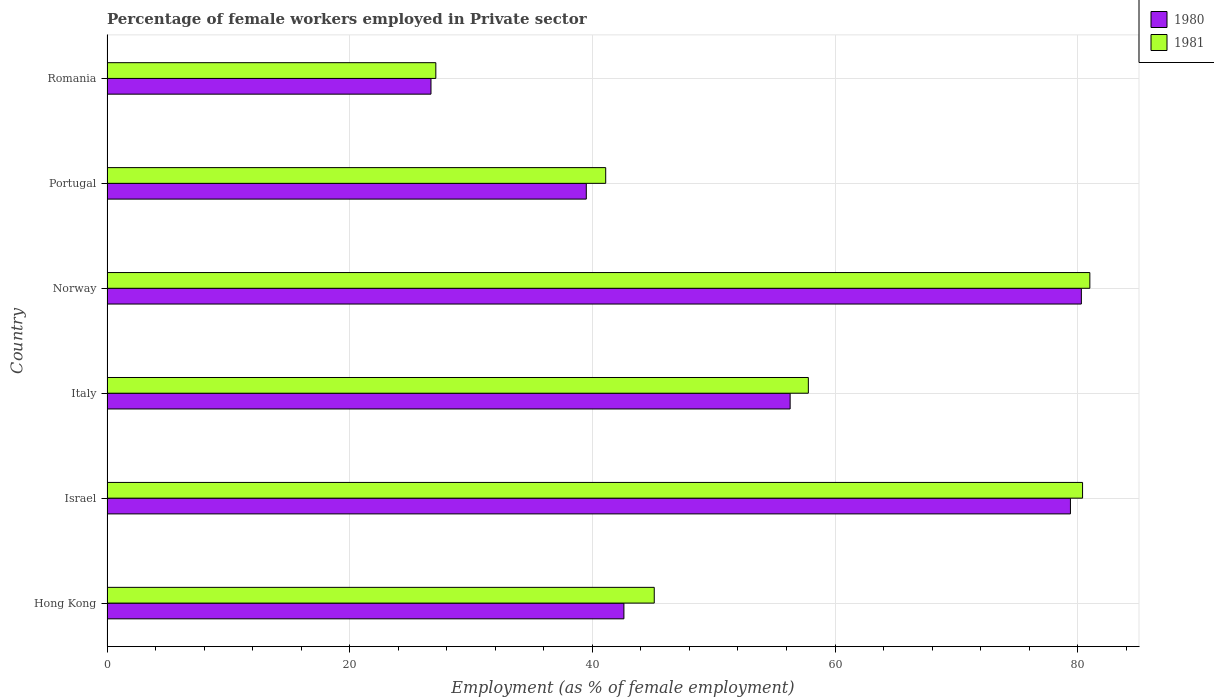How many bars are there on the 3rd tick from the top?
Your answer should be very brief. 2. How many bars are there on the 6th tick from the bottom?
Provide a short and direct response. 2. What is the label of the 2nd group of bars from the top?
Make the answer very short. Portugal. What is the percentage of females employed in Private sector in 1980 in Italy?
Offer a very short reply. 56.3. Across all countries, what is the maximum percentage of females employed in Private sector in 1980?
Give a very brief answer. 80.3. Across all countries, what is the minimum percentage of females employed in Private sector in 1981?
Offer a very short reply. 27.1. In which country was the percentage of females employed in Private sector in 1981 minimum?
Give a very brief answer. Romania. What is the total percentage of females employed in Private sector in 1981 in the graph?
Provide a succinct answer. 332.5. What is the difference between the percentage of females employed in Private sector in 1980 in Portugal and that in Romania?
Keep it short and to the point. 12.8. What is the difference between the percentage of females employed in Private sector in 1980 in Israel and the percentage of females employed in Private sector in 1981 in Norway?
Make the answer very short. -1.6. What is the average percentage of females employed in Private sector in 1980 per country?
Your response must be concise. 54.13. What is the difference between the percentage of females employed in Private sector in 1980 and percentage of females employed in Private sector in 1981 in Romania?
Provide a succinct answer. -0.4. In how many countries, is the percentage of females employed in Private sector in 1980 greater than 20 %?
Keep it short and to the point. 6. What is the ratio of the percentage of females employed in Private sector in 1980 in Hong Kong to that in Portugal?
Your response must be concise. 1.08. Is the percentage of females employed in Private sector in 1981 in Hong Kong less than that in Romania?
Your answer should be compact. No. Is the difference between the percentage of females employed in Private sector in 1980 in Italy and Norway greater than the difference between the percentage of females employed in Private sector in 1981 in Italy and Norway?
Make the answer very short. No. What is the difference between the highest and the second highest percentage of females employed in Private sector in 1981?
Offer a terse response. 0.6. What is the difference between the highest and the lowest percentage of females employed in Private sector in 1981?
Ensure brevity in your answer.  53.9. What does the 2nd bar from the bottom in Hong Kong represents?
Your response must be concise. 1981. Does the graph contain grids?
Your answer should be compact. Yes. How are the legend labels stacked?
Keep it short and to the point. Vertical. What is the title of the graph?
Offer a very short reply. Percentage of female workers employed in Private sector. Does "1994" appear as one of the legend labels in the graph?
Your answer should be very brief. No. What is the label or title of the X-axis?
Give a very brief answer. Employment (as % of female employment). What is the Employment (as % of female employment) of 1980 in Hong Kong?
Provide a succinct answer. 42.6. What is the Employment (as % of female employment) in 1981 in Hong Kong?
Keep it short and to the point. 45.1. What is the Employment (as % of female employment) of 1980 in Israel?
Provide a succinct answer. 79.4. What is the Employment (as % of female employment) in 1981 in Israel?
Provide a succinct answer. 80.4. What is the Employment (as % of female employment) in 1980 in Italy?
Give a very brief answer. 56.3. What is the Employment (as % of female employment) in 1981 in Italy?
Your response must be concise. 57.8. What is the Employment (as % of female employment) of 1980 in Norway?
Provide a succinct answer. 80.3. What is the Employment (as % of female employment) in 1981 in Norway?
Provide a short and direct response. 81. What is the Employment (as % of female employment) of 1980 in Portugal?
Your answer should be very brief. 39.5. What is the Employment (as % of female employment) of 1981 in Portugal?
Your answer should be compact. 41.1. What is the Employment (as % of female employment) of 1980 in Romania?
Provide a succinct answer. 26.7. What is the Employment (as % of female employment) of 1981 in Romania?
Make the answer very short. 27.1. Across all countries, what is the maximum Employment (as % of female employment) in 1980?
Your answer should be compact. 80.3. Across all countries, what is the maximum Employment (as % of female employment) of 1981?
Your answer should be very brief. 81. Across all countries, what is the minimum Employment (as % of female employment) in 1980?
Your response must be concise. 26.7. Across all countries, what is the minimum Employment (as % of female employment) in 1981?
Provide a short and direct response. 27.1. What is the total Employment (as % of female employment) of 1980 in the graph?
Offer a very short reply. 324.8. What is the total Employment (as % of female employment) in 1981 in the graph?
Provide a succinct answer. 332.5. What is the difference between the Employment (as % of female employment) in 1980 in Hong Kong and that in Israel?
Make the answer very short. -36.8. What is the difference between the Employment (as % of female employment) of 1981 in Hong Kong and that in Israel?
Your answer should be very brief. -35.3. What is the difference between the Employment (as % of female employment) in 1980 in Hong Kong and that in Italy?
Offer a very short reply. -13.7. What is the difference between the Employment (as % of female employment) in 1981 in Hong Kong and that in Italy?
Keep it short and to the point. -12.7. What is the difference between the Employment (as % of female employment) in 1980 in Hong Kong and that in Norway?
Offer a terse response. -37.7. What is the difference between the Employment (as % of female employment) in 1981 in Hong Kong and that in Norway?
Make the answer very short. -35.9. What is the difference between the Employment (as % of female employment) in 1980 in Hong Kong and that in Portugal?
Your response must be concise. 3.1. What is the difference between the Employment (as % of female employment) in 1981 in Hong Kong and that in Romania?
Provide a succinct answer. 18. What is the difference between the Employment (as % of female employment) in 1980 in Israel and that in Italy?
Ensure brevity in your answer.  23.1. What is the difference between the Employment (as % of female employment) of 1981 in Israel and that in Italy?
Ensure brevity in your answer.  22.6. What is the difference between the Employment (as % of female employment) in 1980 in Israel and that in Norway?
Your answer should be very brief. -0.9. What is the difference between the Employment (as % of female employment) in 1981 in Israel and that in Norway?
Keep it short and to the point. -0.6. What is the difference between the Employment (as % of female employment) in 1980 in Israel and that in Portugal?
Your answer should be compact. 39.9. What is the difference between the Employment (as % of female employment) in 1981 in Israel and that in Portugal?
Provide a short and direct response. 39.3. What is the difference between the Employment (as % of female employment) of 1980 in Israel and that in Romania?
Offer a terse response. 52.7. What is the difference between the Employment (as % of female employment) in 1981 in Israel and that in Romania?
Your response must be concise. 53.3. What is the difference between the Employment (as % of female employment) of 1980 in Italy and that in Norway?
Your answer should be very brief. -24. What is the difference between the Employment (as % of female employment) of 1981 in Italy and that in Norway?
Offer a terse response. -23.2. What is the difference between the Employment (as % of female employment) in 1980 in Italy and that in Portugal?
Give a very brief answer. 16.8. What is the difference between the Employment (as % of female employment) of 1980 in Italy and that in Romania?
Offer a terse response. 29.6. What is the difference between the Employment (as % of female employment) of 1981 in Italy and that in Romania?
Make the answer very short. 30.7. What is the difference between the Employment (as % of female employment) of 1980 in Norway and that in Portugal?
Provide a succinct answer. 40.8. What is the difference between the Employment (as % of female employment) of 1981 in Norway and that in Portugal?
Offer a terse response. 39.9. What is the difference between the Employment (as % of female employment) of 1980 in Norway and that in Romania?
Provide a short and direct response. 53.6. What is the difference between the Employment (as % of female employment) in 1981 in Norway and that in Romania?
Make the answer very short. 53.9. What is the difference between the Employment (as % of female employment) in 1980 in Portugal and that in Romania?
Offer a terse response. 12.8. What is the difference between the Employment (as % of female employment) in 1980 in Hong Kong and the Employment (as % of female employment) in 1981 in Israel?
Your answer should be compact. -37.8. What is the difference between the Employment (as % of female employment) of 1980 in Hong Kong and the Employment (as % of female employment) of 1981 in Italy?
Provide a succinct answer. -15.2. What is the difference between the Employment (as % of female employment) in 1980 in Hong Kong and the Employment (as % of female employment) in 1981 in Norway?
Ensure brevity in your answer.  -38.4. What is the difference between the Employment (as % of female employment) in 1980 in Hong Kong and the Employment (as % of female employment) in 1981 in Portugal?
Offer a very short reply. 1.5. What is the difference between the Employment (as % of female employment) of 1980 in Hong Kong and the Employment (as % of female employment) of 1981 in Romania?
Provide a succinct answer. 15.5. What is the difference between the Employment (as % of female employment) in 1980 in Israel and the Employment (as % of female employment) in 1981 in Italy?
Offer a terse response. 21.6. What is the difference between the Employment (as % of female employment) in 1980 in Israel and the Employment (as % of female employment) in 1981 in Norway?
Keep it short and to the point. -1.6. What is the difference between the Employment (as % of female employment) of 1980 in Israel and the Employment (as % of female employment) of 1981 in Portugal?
Offer a very short reply. 38.3. What is the difference between the Employment (as % of female employment) of 1980 in Israel and the Employment (as % of female employment) of 1981 in Romania?
Ensure brevity in your answer.  52.3. What is the difference between the Employment (as % of female employment) of 1980 in Italy and the Employment (as % of female employment) of 1981 in Norway?
Ensure brevity in your answer.  -24.7. What is the difference between the Employment (as % of female employment) in 1980 in Italy and the Employment (as % of female employment) in 1981 in Romania?
Your answer should be compact. 29.2. What is the difference between the Employment (as % of female employment) of 1980 in Norway and the Employment (as % of female employment) of 1981 in Portugal?
Provide a short and direct response. 39.2. What is the difference between the Employment (as % of female employment) in 1980 in Norway and the Employment (as % of female employment) in 1981 in Romania?
Your response must be concise. 53.2. What is the average Employment (as % of female employment) of 1980 per country?
Make the answer very short. 54.13. What is the average Employment (as % of female employment) in 1981 per country?
Give a very brief answer. 55.42. What is the difference between the Employment (as % of female employment) of 1980 and Employment (as % of female employment) of 1981 in Norway?
Your answer should be very brief. -0.7. What is the difference between the Employment (as % of female employment) of 1980 and Employment (as % of female employment) of 1981 in Romania?
Offer a terse response. -0.4. What is the ratio of the Employment (as % of female employment) in 1980 in Hong Kong to that in Israel?
Your response must be concise. 0.54. What is the ratio of the Employment (as % of female employment) in 1981 in Hong Kong to that in Israel?
Make the answer very short. 0.56. What is the ratio of the Employment (as % of female employment) of 1980 in Hong Kong to that in Italy?
Keep it short and to the point. 0.76. What is the ratio of the Employment (as % of female employment) of 1981 in Hong Kong to that in Italy?
Your answer should be compact. 0.78. What is the ratio of the Employment (as % of female employment) of 1980 in Hong Kong to that in Norway?
Ensure brevity in your answer.  0.53. What is the ratio of the Employment (as % of female employment) in 1981 in Hong Kong to that in Norway?
Keep it short and to the point. 0.56. What is the ratio of the Employment (as % of female employment) of 1980 in Hong Kong to that in Portugal?
Ensure brevity in your answer.  1.08. What is the ratio of the Employment (as % of female employment) of 1981 in Hong Kong to that in Portugal?
Keep it short and to the point. 1.1. What is the ratio of the Employment (as % of female employment) in 1980 in Hong Kong to that in Romania?
Provide a short and direct response. 1.6. What is the ratio of the Employment (as % of female employment) in 1981 in Hong Kong to that in Romania?
Provide a short and direct response. 1.66. What is the ratio of the Employment (as % of female employment) of 1980 in Israel to that in Italy?
Give a very brief answer. 1.41. What is the ratio of the Employment (as % of female employment) of 1981 in Israel to that in Italy?
Provide a succinct answer. 1.39. What is the ratio of the Employment (as % of female employment) in 1981 in Israel to that in Norway?
Keep it short and to the point. 0.99. What is the ratio of the Employment (as % of female employment) of 1980 in Israel to that in Portugal?
Your answer should be very brief. 2.01. What is the ratio of the Employment (as % of female employment) of 1981 in Israel to that in Portugal?
Your answer should be compact. 1.96. What is the ratio of the Employment (as % of female employment) of 1980 in Israel to that in Romania?
Provide a short and direct response. 2.97. What is the ratio of the Employment (as % of female employment) of 1981 in Israel to that in Romania?
Your answer should be compact. 2.97. What is the ratio of the Employment (as % of female employment) of 1980 in Italy to that in Norway?
Your answer should be very brief. 0.7. What is the ratio of the Employment (as % of female employment) of 1981 in Italy to that in Norway?
Give a very brief answer. 0.71. What is the ratio of the Employment (as % of female employment) in 1980 in Italy to that in Portugal?
Make the answer very short. 1.43. What is the ratio of the Employment (as % of female employment) of 1981 in Italy to that in Portugal?
Ensure brevity in your answer.  1.41. What is the ratio of the Employment (as % of female employment) in 1980 in Italy to that in Romania?
Your response must be concise. 2.11. What is the ratio of the Employment (as % of female employment) of 1981 in Italy to that in Romania?
Your answer should be compact. 2.13. What is the ratio of the Employment (as % of female employment) in 1980 in Norway to that in Portugal?
Your answer should be compact. 2.03. What is the ratio of the Employment (as % of female employment) in 1981 in Norway to that in Portugal?
Offer a very short reply. 1.97. What is the ratio of the Employment (as % of female employment) of 1980 in Norway to that in Romania?
Ensure brevity in your answer.  3.01. What is the ratio of the Employment (as % of female employment) of 1981 in Norway to that in Romania?
Give a very brief answer. 2.99. What is the ratio of the Employment (as % of female employment) in 1980 in Portugal to that in Romania?
Provide a succinct answer. 1.48. What is the ratio of the Employment (as % of female employment) in 1981 in Portugal to that in Romania?
Your answer should be very brief. 1.52. What is the difference between the highest and the lowest Employment (as % of female employment) of 1980?
Your answer should be very brief. 53.6. What is the difference between the highest and the lowest Employment (as % of female employment) of 1981?
Ensure brevity in your answer.  53.9. 